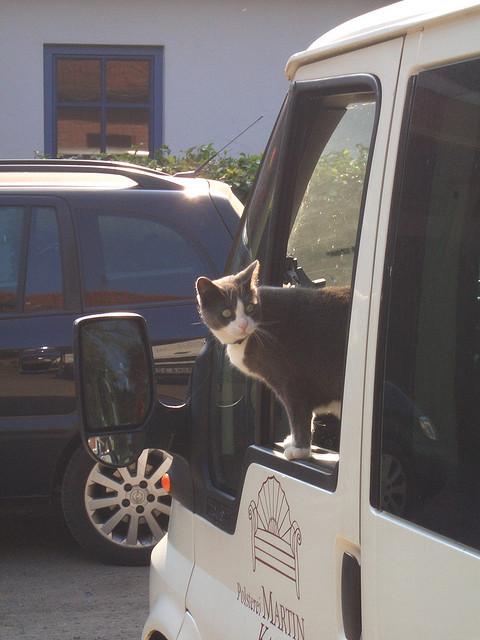What name is on the door?
Concise answer only. Martin. How many wheels does the van have?
Short answer required. 4. Is the cat playing?
Be succinct. No. What is the drawing on the white van's door?
Give a very brief answer. Chair. What color is the cat?
Keep it brief. Gray and white. What part of the car is the cat sitting on?
Keep it brief. Window. What is in the picture?
Write a very short answer. Cat. How many vehicles are there?
Answer briefly. 2. What is the cat staring at?
Keep it brief. Car. 